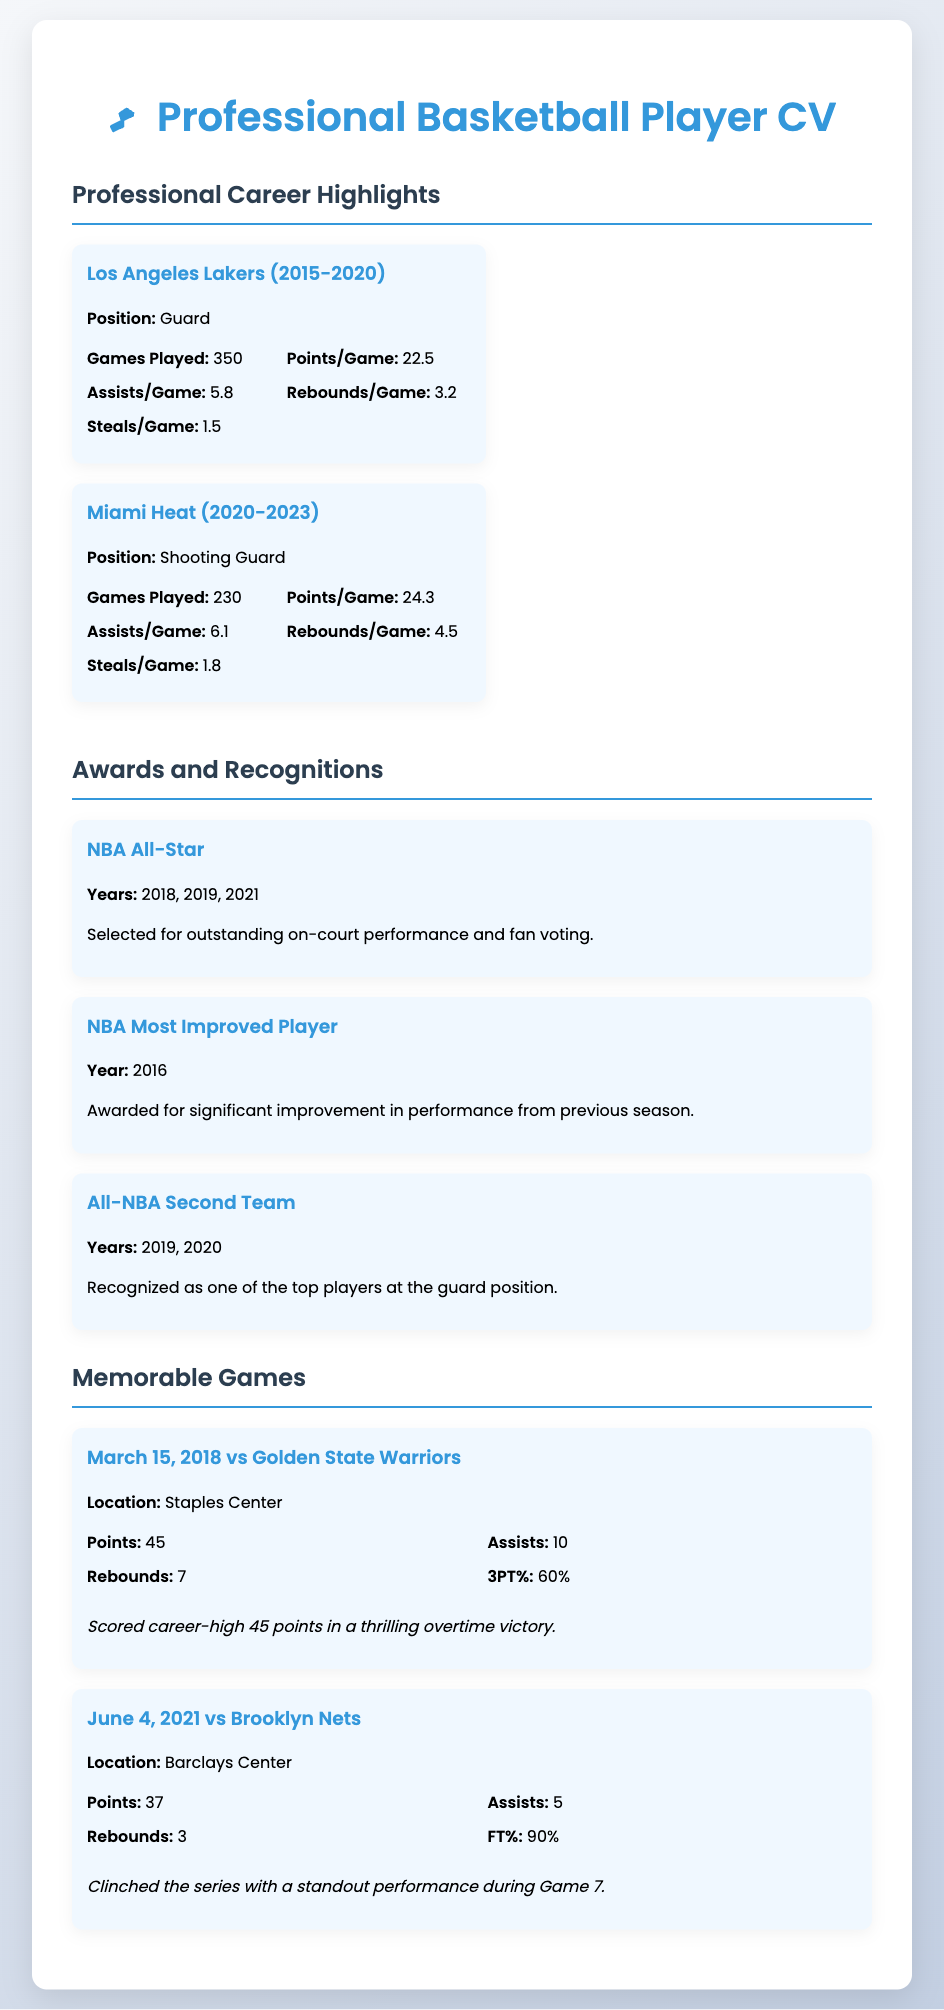What was the player's position with the Los Angeles Lakers? The position is listed as "Guard" under the Los Angeles Lakers section in the CV.
Answer: Guard How many games did the player play for the Miami Heat? The number of games played for the Miami Heat is stated as "230" in the relevant section of the CV.
Answer: 230 What year did the player receive the NBA Most Improved Player award? The year of the award is mentioned as "2016" in the Awards section.
Answer: 2016 Which team did the player score 45 points against on March 15, 2018? The game details specify that the opponent was the "Golden State Warriors."
Answer: Golden State Warriors How many times was the player selected as an NBA All-Star? The years of selection listed are "2018, 2019, 2021," indicating a total of three selections.
Answer: 3 What was the player's points per game average for the Miami Heat? The average is specified as "24.3" points per game in the Miami Heat section of the CV.
Answer: 24.3 In what year did the player achieve All-NBA Second Team recognition? The years mentioned are "2019, 2020," which indicates that the player was recognized in those years.
Answer: 2019, 2020 What was the player's free throw percentage in the memorable game on June 4, 2021? The free throw percentage is listed as "90%" in the game details.
Answer: 90% What is the total number of games played by the player across both teams? The total can be calculated by adding the games played: 350 (Lakers) + 230 (Heat) = 580.
Answer: 580 